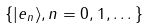<formula> <loc_0><loc_0><loc_500><loc_500>\{ | e _ { n } \rangle , n = 0 , 1 , \dots \}</formula> 